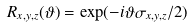<formula> <loc_0><loc_0><loc_500><loc_500>R _ { x , y , z } ( \vartheta ) = \exp ( - i \vartheta \sigma _ { x , y , z } / 2 )</formula> 